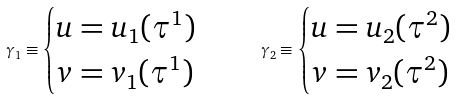Convert formula to latex. <formula><loc_0><loc_0><loc_500><loc_500>\gamma _ { 1 } \equiv \begin{cases} u = u _ { 1 } ( \tau ^ { 1 } ) \\ v = v _ { 1 } ( \tau ^ { 1 } ) \end{cases} \quad \gamma _ { 2 } \equiv \begin{cases} u = u _ { 2 } ( \tau ^ { 2 } ) \\ v = v _ { 2 } ( \tau ^ { 2 } ) \end{cases}</formula> 